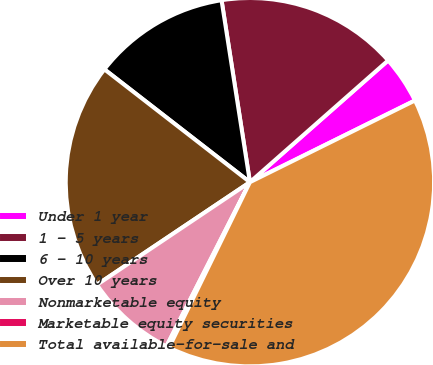Convert chart to OTSL. <chart><loc_0><loc_0><loc_500><loc_500><pie_chart><fcel>Under 1 year<fcel>1 - 5 years<fcel>6 - 10 years<fcel>Over 10 years<fcel>Nonmarketable equity<fcel>Marketable equity securities<fcel>Total available-for-sale and<nl><fcel>4.18%<fcel>15.97%<fcel>12.04%<fcel>19.9%<fcel>8.11%<fcel>0.25%<fcel>39.56%<nl></chart> 